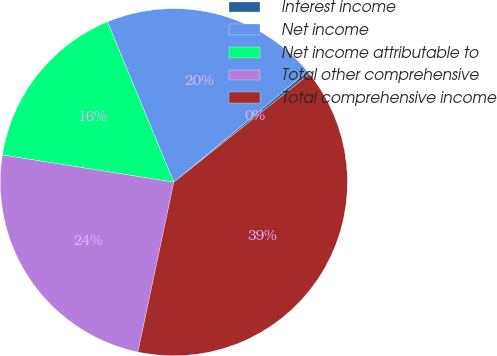Convert chart. <chart><loc_0><loc_0><loc_500><loc_500><pie_chart><fcel>Interest income<fcel>Net income<fcel>Net income attributable to<fcel>Total other comprehensive<fcel>Total comprehensive income<nl><fcel>0.3%<fcel>20.22%<fcel>16.25%<fcel>24.19%<fcel>39.05%<nl></chart> 